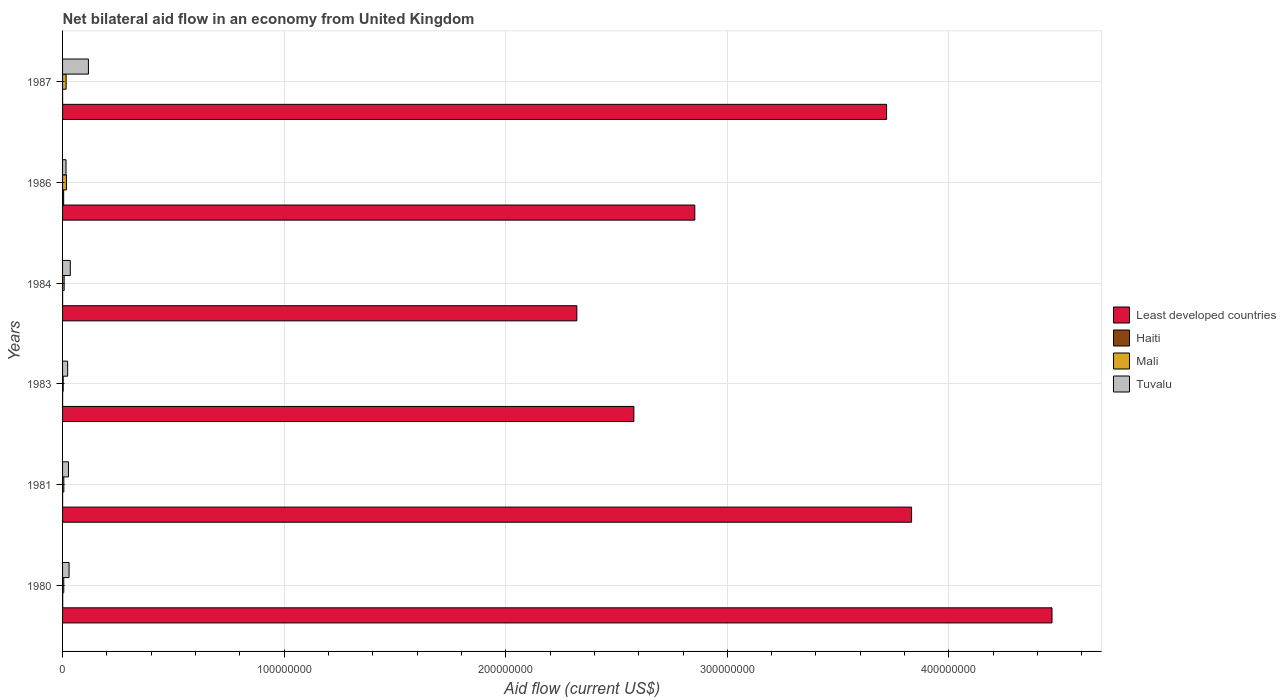How many different coloured bars are there?
Offer a terse response. 4. How many groups of bars are there?
Ensure brevity in your answer.  6. Are the number of bars per tick equal to the number of legend labels?
Offer a terse response. Yes. Are the number of bars on each tick of the Y-axis equal?
Your answer should be very brief. Yes. How many bars are there on the 1st tick from the top?
Make the answer very short. 4. How many bars are there on the 5th tick from the bottom?
Make the answer very short. 4. What is the label of the 4th group of bars from the top?
Your answer should be compact. 1983. What is the net bilateral aid flow in Least developed countries in 1986?
Your answer should be compact. 2.85e+08. Across all years, what is the maximum net bilateral aid flow in Haiti?
Keep it short and to the point. 4.90e+05. In which year was the net bilateral aid flow in Least developed countries maximum?
Give a very brief answer. 1980. What is the difference between the net bilateral aid flow in Least developed countries in 1980 and that in 1983?
Your response must be concise. 1.89e+08. What is the difference between the net bilateral aid flow in Haiti in 1981 and the net bilateral aid flow in Mali in 1986?
Ensure brevity in your answer.  -1.73e+06. What is the average net bilateral aid flow in Mali per year?
Provide a short and direct response. 9.10e+05. In the year 1981, what is the difference between the net bilateral aid flow in Tuvalu and net bilateral aid flow in Haiti?
Your answer should be very brief. 2.65e+06. In how many years, is the net bilateral aid flow in Haiti greater than 240000000 US$?
Give a very brief answer. 0. What is the ratio of the net bilateral aid flow in Least developed countries in 1981 to that in 1983?
Your response must be concise. 1.49. Is the net bilateral aid flow in Haiti in 1980 less than that in 1981?
Keep it short and to the point. No. Is the difference between the net bilateral aid flow in Tuvalu in 1980 and 1987 greater than the difference between the net bilateral aid flow in Haiti in 1980 and 1987?
Keep it short and to the point. No. What is the difference between the highest and the second highest net bilateral aid flow in Tuvalu?
Your answer should be compact. 8.18e+06. Is the sum of the net bilateral aid flow in Mali in 1984 and 1986 greater than the maximum net bilateral aid flow in Least developed countries across all years?
Give a very brief answer. No. What does the 2nd bar from the top in 1980 represents?
Keep it short and to the point. Mali. What does the 4th bar from the bottom in 1984 represents?
Provide a short and direct response. Tuvalu. Is it the case that in every year, the sum of the net bilateral aid flow in Mali and net bilateral aid flow in Least developed countries is greater than the net bilateral aid flow in Tuvalu?
Offer a terse response. Yes. How many bars are there?
Keep it short and to the point. 24. Are all the bars in the graph horizontal?
Give a very brief answer. Yes. How many years are there in the graph?
Offer a terse response. 6. What is the difference between two consecutive major ticks on the X-axis?
Make the answer very short. 1.00e+08. Are the values on the major ticks of X-axis written in scientific E-notation?
Keep it short and to the point. No. Does the graph contain any zero values?
Give a very brief answer. No. Does the graph contain grids?
Your answer should be compact. Yes. Where does the legend appear in the graph?
Provide a succinct answer. Center right. How many legend labels are there?
Your answer should be compact. 4. How are the legend labels stacked?
Provide a succinct answer. Vertical. What is the title of the graph?
Your answer should be compact. Net bilateral aid flow in an economy from United Kingdom. What is the label or title of the X-axis?
Your answer should be very brief. Aid flow (current US$). What is the label or title of the Y-axis?
Ensure brevity in your answer.  Years. What is the Aid flow (current US$) in Least developed countries in 1980?
Keep it short and to the point. 4.47e+08. What is the Aid flow (current US$) of Mali in 1980?
Ensure brevity in your answer.  5.40e+05. What is the Aid flow (current US$) of Tuvalu in 1980?
Offer a very short reply. 2.93e+06. What is the Aid flow (current US$) in Least developed countries in 1981?
Offer a very short reply. 3.83e+08. What is the Aid flow (current US$) in Haiti in 1981?
Make the answer very short. 10000. What is the Aid flow (current US$) in Mali in 1981?
Keep it short and to the point. 5.70e+05. What is the Aid flow (current US$) in Tuvalu in 1981?
Your response must be concise. 2.66e+06. What is the Aid flow (current US$) in Least developed countries in 1983?
Provide a succinct answer. 2.58e+08. What is the Aid flow (current US$) in Tuvalu in 1983?
Your answer should be very brief. 2.30e+06. What is the Aid flow (current US$) of Least developed countries in 1984?
Ensure brevity in your answer.  2.32e+08. What is the Aid flow (current US$) of Mali in 1984?
Keep it short and to the point. 7.10e+05. What is the Aid flow (current US$) in Tuvalu in 1984?
Provide a succinct answer. 3.49e+06. What is the Aid flow (current US$) of Least developed countries in 1986?
Provide a short and direct response. 2.85e+08. What is the Aid flow (current US$) in Mali in 1986?
Keep it short and to the point. 1.74e+06. What is the Aid flow (current US$) in Tuvalu in 1986?
Your response must be concise. 1.56e+06. What is the Aid flow (current US$) in Least developed countries in 1987?
Your response must be concise. 3.72e+08. What is the Aid flow (current US$) in Mali in 1987?
Keep it short and to the point. 1.61e+06. What is the Aid flow (current US$) of Tuvalu in 1987?
Make the answer very short. 1.17e+07. Across all years, what is the maximum Aid flow (current US$) of Least developed countries?
Your answer should be very brief. 4.47e+08. Across all years, what is the maximum Aid flow (current US$) in Mali?
Make the answer very short. 1.74e+06. Across all years, what is the maximum Aid flow (current US$) of Tuvalu?
Your answer should be compact. 1.17e+07. Across all years, what is the minimum Aid flow (current US$) in Least developed countries?
Provide a succinct answer. 2.32e+08. Across all years, what is the minimum Aid flow (current US$) in Haiti?
Ensure brevity in your answer.  10000. Across all years, what is the minimum Aid flow (current US$) in Mali?
Provide a short and direct response. 2.90e+05. Across all years, what is the minimum Aid flow (current US$) in Tuvalu?
Give a very brief answer. 1.56e+06. What is the total Aid flow (current US$) in Least developed countries in the graph?
Give a very brief answer. 1.98e+09. What is the total Aid flow (current US$) of Mali in the graph?
Your answer should be compact. 5.46e+06. What is the total Aid flow (current US$) in Tuvalu in the graph?
Your response must be concise. 2.46e+07. What is the difference between the Aid flow (current US$) in Least developed countries in 1980 and that in 1981?
Your response must be concise. 6.34e+07. What is the difference between the Aid flow (current US$) in Haiti in 1980 and that in 1981?
Give a very brief answer. 5.00e+04. What is the difference between the Aid flow (current US$) of Tuvalu in 1980 and that in 1981?
Make the answer very short. 2.70e+05. What is the difference between the Aid flow (current US$) in Least developed countries in 1980 and that in 1983?
Provide a short and direct response. 1.89e+08. What is the difference between the Aid flow (current US$) in Mali in 1980 and that in 1983?
Offer a terse response. 2.50e+05. What is the difference between the Aid flow (current US$) of Tuvalu in 1980 and that in 1983?
Ensure brevity in your answer.  6.30e+05. What is the difference between the Aid flow (current US$) in Least developed countries in 1980 and that in 1984?
Your answer should be compact. 2.14e+08. What is the difference between the Aid flow (current US$) in Haiti in 1980 and that in 1984?
Offer a terse response. 5.00e+04. What is the difference between the Aid flow (current US$) of Mali in 1980 and that in 1984?
Make the answer very short. -1.70e+05. What is the difference between the Aid flow (current US$) in Tuvalu in 1980 and that in 1984?
Your answer should be very brief. -5.60e+05. What is the difference between the Aid flow (current US$) in Least developed countries in 1980 and that in 1986?
Your response must be concise. 1.61e+08. What is the difference between the Aid flow (current US$) in Haiti in 1980 and that in 1986?
Offer a very short reply. -4.30e+05. What is the difference between the Aid flow (current US$) of Mali in 1980 and that in 1986?
Your response must be concise. -1.20e+06. What is the difference between the Aid flow (current US$) in Tuvalu in 1980 and that in 1986?
Give a very brief answer. 1.37e+06. What is the difference between the Aid flow (current US$) in Least developed countries in 1980 and that in 1987?
Give a very brief answer. 7.46e+07. What is the difference between the Aid flow (current US$) in Haiti in 1980 and that in 1987?
Ensure brevity in your answer.  5.00e+04. What is the difference between the Aid flow (current US$) of Mali in 1980 and that in 1987?
Your response must be concise. -1.07e+06. What is the difference between the Aid flow (current US$) of Tuvalu in 1980 and that in 1987?
Your answer should be very brief. -8.74e+06. What is the difference between the Aid flow (current US$) in Least developed countries in 1981 and that in 1983?
Provide a succinct answer. 1.25e+08. What is the difference between the Aid flow (current US$) of Least developed countries in 1981 and that in 1984?
Offer a terse response. 1.51e+08. What is the difference between the Aid flow (current US$) of Tuvalu in 1981 and that in 1984?
Make the answer very short. -8.30e+05. What is the difference between the Aid flow (current US$) of Least developed countries in 1981 and that in 1986?
Your answer should be very brief. 9.78e+07. What is the difference between the Aid flow (current US$) in Haiti in 1981 and that in 1986?
Your answer should be compact. -4.80e+05. What is the difference between the Aid flow (current US$) of Mali in 1981 and that in 1986?
Keep it short and to the point. -1.17e+06. What is the difference between the Aid flow (current US$) in Tuvalu in 1981 and that in 1986?
Your answer should be very brief. 1.10e+06. What is the difference between the Aid flow (current US$) of Least developed countries in 1981 and that in 1987?
Offer a terse response. 1.13e+07. What is the difference between the Aid flow (current US$) of Mali in 1981 and that in 1987?
Ensure brevity in your answer.  -1.04e+06. What is the difference between the Aid flow (current US$) of Tuvalu in 1981 and that in 1987?
Your response must be concise. -9.01e+06. What is the difference between the Aid flow (current US$) of Least developed countries in 1983 and that in 1984?
Offer a terse response. 2.57e+07. What is the difference between the Aid flow (current US$) in Haiti in 1983 and that in 1984?
Your answer should be very brief. 2.00e+04. What is the difference between the Aid flow (current US$) of Mali in 1983 and that in 1984?
Provide a succinct answer. -4.20e+05. What is the difference between the Aid flow (current US$) in Tuvalu in 1983 and that in 1984?
Offer a very short reply. -1.19e+06. What is the difference between the Aid flow (current US$) of Least developed countries in 1983 and that in 1986?
Ensure brevity in your answer.  -2.75e+07. What is the difference between the Aid flow (current US$) in Haiti in 1983 and that in 1986?
Your answer should be compact. -4.60e+05. What is the difference between the Aid flow (current US$) in Mali in 1983 and that in 1986?
Provide a short and direct response. -1.45e+06. What is the difference between the Aid flow (current US$) of Tuvalu in 1983 and that in 1986?
Ensure brevity in your answer.  7.40e+05. What is the difference between the Aid flow (current US$) of Least developed countries in 1983 and that in 1987?
Offer a terse response. -1.14e+08. What is the difference between the Aid flow (current US$) in Haiti in 1983 and that in 1987?
Offer a very short reply. 2.00e+04. What is the difference between the Aid flow (current US$) in Mali in 1983 and that in 1987?
Your answer should be compact. -1.32e+06. What is the difference between the Aid flow (current US$) in Tuvalu in 1983 and that in 1987?
Your response must be concise. -9.37e+06. What is the difference between the Aid flow (current US$) of Least developed countries in 1984 and that in 1986?
Give a very brief answer. -5.32e+07. What is the difference between the Aid flow (current US$) in Haiti in 1984 and that in 1986?
Your answer should be compact. -4.80e+05. What is the difference between the Aid flow (current US$) in Mali in 1984 and that in 1986?
Your response must be concise. -1.03e+06. What is the difference between the Aid flow (current US$) in Tuvalu in 1984 and that in 1986?
Your response must be concise. 1.93e+06. What is the difference between the Aid flow (current US$) in Least developed countries in 1984 and that in 1987?
Your answer should be compact. -1.40e+08. What is the difference between the Aid flow (current US$) of Haiti in 1984 and that in 1987?
Offer a terse response. 0. What is the difference between the Aid flow (current US$) in Mali in 1984 and that in 1987?
Provide a succinct answer. -9.00e+05. What is the difference between the Aid flow (current US$) in Tuvalu in 1984 and that in 1987?
Ensure brevity in your answer.  -8.18e+06. What is the difference between the Aid flow (current US$) in Least developed countries in 1986 and that in 1987?
Give a very brief answer. -8.66e+07. What is the difference between the Aid flow (current US$) of Haiti in 1986 and that in 1987?
Your response must be concise. 4.80e+05. What is the difference between the Aid flow (current US$) of Tuvalu in 1986 and that in 1987?
Offer a terse response. -1.01e+07. What is the difference between the Aid flow (current US$) of Least developed countries in 1980 and the Aid flow (current US$) of Haiti in 1981?
Ensure brevity in your answer.  4.46e+08. What is the difference between the Aid flow (current US$) in Least developed countries in 1980 and the Aid flow (current US$) in Mali in 1981?
Provide a succinct answer. 4.46e+08. What is the difference between the Aid flow (current US$) in Least developed countries in 1980 and the Aid flow (current US$) in Tuvalu in 1981?
Your answer should be very brief. 4.44e+08. What is the difference between the Aid flow (current US$) in Haiti in 1980 and the Aid flow (current US$) in Mali in 1981?
Provide a succinct answer. -5.10e+05. What is the difference between the Aid flow (current US$) of Haiti in 1980 and the Aid flow (current US$) of Tuvalu in 1981?
Offer a very short reply. -2.60e+06. What is the difference between the Aid flow (current US$) of Mali in 1980 and the Aid flow (current US$) of Tuvalu in 1981?
Your answer should be compact. -2.12e+06. What is the difference between the Aid flow (current US$) in Least developed countries in 1980 and the Aid flow (current US$) in Haiti in 1983?
Keep it short and to the point. 4.46e+08. What is the difference between the Aid flow (current US$) of Least developed countries in 1980 and the Aid flow (current US$) of Mali in 1983?
Your answer should be very brief. 4.46e+08. What is the difference between the Aid flow (current US$) in Least developed countries in 1980 and the Aid flow (current US$) in Tuvalu in 1983?
Provide a succinct answer. 4.44e+08. What is the difference between the Aid flow (current US$) of Haiti in 1980 and the Aid flow (current US$) of Mali in 1983?
Offer a terse response. -2.30e+05. What is the difference between the Aid flow (current US$) in Haiti in 1980 and the Aid flow (current US$) in Tuvalu in 1983?
Your response must be concise. -2.24e+06. What is the difference between the Aid flow (current US$) in Mali in 1980 and the Aid flow (current US$) in Tuvalu in 1983?
Keep it short and to the point. -1.76e+06. What is the difference between the Aid flow (current US$) in Least developed countries in 1980 and the Aid flow (current US$) in Haiti in 1984?
Your answer should be compact. 4.46e+08. What is the difference between the Aid flow (current US$) of Least developed countries in 1980 and the Aid flow (current US$) of Mali in 1984?
Make the answer very short. 4.46e+08. What is the difference between the Aid flow (current US$) in Least developed countries in 1980 and the Aid flow (current US$) in Tuvalu in 1984?
Your answer should be compact. 4.43e+08. What is the difference between the Aid flow (current US$) of Haiti in 1980 and the Aid flow (current US$) of Mali in 1984?
Keep it short and to the point. -6.50e+05. What is the difference between the Aid flow (current US$) in Haiti in 1980 and the Aid flow (current US$) in Tuvalu in 1984?
Provide a succinct answer. -3.43e+06. What is the difference between the Aid flow (current US$) of Mali in 1980 and the Aid flow (current US$) of Tuvalu in 1984?
Your answer should be very brief. -2.95e+06. What is the difference between the Aid flow (current US$) in Least developed countries in 1980 and the Aid flow (current US$) in Haiti in 1986?
Offer a very short reply. 4.46e+08. What is the difference between the Aid flow (current US$) of Least developed countries in 1980 and the Aid flow (current US$) of Mali in 1986?
Make the answer very short. 4.45e+08. What is the difference between the Aid flow (current US$) in Least developed countries in 1980 and the Aid flow (current US$) in Tuvalu in 1986?
Provide a succinct answer. 4.45e+08. What is the difference between the Aid flow (current US$) of Haiti in 1980 and the Aid flow (current US$) of Mali in 1986?
Make the answer very short. -1.68e+06. What is the difference between the Aid flow (current US$) of Haiti in 1980 and the Aid flow (current US$) of Tuvalu in 1986?
Offer a terse response. -1.50e+06. What is the difference between the Aid flow (current US$) in Mali in 1980 and the Aid flow (current US$) in Tuvalu in 1986?
Ensure brevity in your answer.  -1.02e+06. What is the difference between the Aid flow (current US$) of Least developed countries in 1980 and the Aid flow (current US$) of Haiti in 1987?
Give a very brief answer. 4.46e+08. What is the difference between the Aid flow (current US$) of Least developed countries in 1980 and the Aid flow (current US$) of Mali in 1987?
Provide a short and direct response. 4.45e+08. What is the difference between the Aid flow (current US$) of Least developed countries in 1980 and the Aid flow (current US$) of Tuvalu in 1987?
Provide a succinct answer. 4.35e+08. What is the difference between the Aid flow (current US$) of Haiti in 1980 and the Aid flow (current US$) of Mali in 1987?
Offer a very short reply. -1.55e+06. What is the difference between the Aid flow (current US$) of Haiti in 1980 and the Aid flow (current US$) of Tuvalu in 1987?
Keep it short and to the point. -1.16e+07. What is the difference between the Aid flow (current US$) of Mali in 1980 and the Aid flow (current US$) of Tuvalu in 1987?
Provide a short and direct response. -1.11e+07. What is the difference between the Aid flow (current US$) of Least developed countries in 1981 and the Aid flow (current US$) of Haiti in 1983?
Provide a succinct answer. 3.83e+08. What is the difference between the Aid flow (current US$) in Least developed countries in 1981 and the Aid flow (current US$) in Mali in 1983?
Offer a very short reply. 3.83e+08. What is the difference between the Aid flow (current US$) in Least developed countries in 1981 and the Aid flow (current US$) in Tuvalu in 1983?
Offer a very short reply. 3.81e+08. What is the difference between the Aid flow (current US$) in Haiti in 1981 and the Aid flow (current US$) in Mali in 1983?
Make the answer very short. -2.80e+05. What is the difference between the Aid flow (current US$) in Haiti in 1981 and the Aid flow (current US$) in Tuvalu in 1983?
Make the answer very short. -2.29e+06. What is the difference between the Aid flow (current US$) in Mali in 1981 and the Aid flow (current US$) in Tuvalu in 1983?
Offer a terse response. -1.73e+06. What is the difference between the Aid flow (current US$) in Least developed countries in 1981 and the Aid flow (current US$) in Haiti in 1984?
Ensure brevity in your answer.  3.83e+08. What is the difference between the Aid flow (current US$) of Least developed countries in 1981 and the Aid flow (current US$) of Mali in 1984?
Keep it short and to the point. 3.82e+08. What is the difference between the Aid flow (current US$) of Least developed countries in 1981 and the Aid flow (current US$) of Tuvalu in 1984?
Keep it short and to the point. 3.80e+08. What is the difference between the Aid flow (current US$) of Haiti in 1981 and the Aid flow (current US$) of Mali in 1984?
Offer a very short reply. -7.00e+05. What is the difference between the Aid flow (current US$) of Haiti in 1981 and the Aid flow (current US$) of Tuvalu in 1984?
Ensure brevity in your answer.  -3.48e+06. What is the difference between the Aid flow (current US$) in Mali in 1981 and the Aid flow (current US$) in Tuvalu in 1984?
Your answer should be very brief. -2.92e+06. What is the difference between the Aid flow (current US$) in Least developed countries in 1981 and the Aid flow (current US$) in Haiti in 1986?
Provide a short and direct response. 3.83e+08. What is the difference between the Aid flow (current US$) in Least developed countries in 1981 and the Aid flow (current US$) in Mali in 1986?
Your response must be concise. 3.81e+08. What is the difference between the Aid flow (current US$) of Least developed countries in 1981 and the Aid flow (current US$) of Tuvalu in 1986?
Ensure brevity in your answer.  3.82e+08. What is the difference between the Aid flow (current US$) in Haiti in 1981 and the Aid flow (current US$) in Mali in 1986?
Make the answer very short. -1.73e+06. What is the difference between the Aid flow (current US$) in Haiti in 1981 and the Aid flow (current US$) in Tuvalu in 1986?
Make the answer very short. -1.55e+06. What is the difference between the Aid flow (current US$) in Mali in 1981 and the Aid flow (current US$) in Tuvalu in 1986?
Keep it short and to the point. -9.90e+05. What is the difference between the Aid flow (current US$) in Least developed countries in 1981 and the Aid flow (current US$) in Haiti in 1987?
Your answer should be very brief. 3.83e+08. What is the difference between the Aid flow (current US$) in Least developed countries in 1981 and the Aid flow (current US$) in Mali in 1987?
Keep it short and to the point. 3.82e+08. What is the difference between the Aid flow (current US$) of Least developed countries in 1981 and the Aid flow (current US$) of Tuvalu in 1987?
Offer a very short reply. 3.71e+08. What is the difference between the Aid flow (current US$) of Haiti in 1981 and the Aid flow (current US$) of Mali in 1987?
Provide a short and direct response. -1.60e+06. What is the difference between the Aid flow (current US$) of Haiti in 1981 and the Aid flow (current US$) of Tuvalu in 1987?
Your response must be concise. -1.17e+07. What is the difference between the Aid flow (current US$) of Mali in 1981 and the Aid flow (current US$) of Tuvalu in 1987?
Keep it short and to the point. -1.11e+07. What is the difference between the Aid flow (current US$) in Least developed countries in 1983 and the Aid flow (current US$) in Haiti in 1984?
Give a very brief answer. 2.58e+08. What is the difference between the Aid flow (current US$) of Least developed countries in 1983 and the Aid flow (current US$) of Mali in 1984?
Your response must be concise. 2.57e+08. What is the difference between the Aid flow (current US$) of Least developed countries in 1983 and the Aid flow (current US$) of Tuvalu in 1984?
Your answer should be compact. 2.54e+08. What is the difference between the Aid flow (current US$) of Haiti in 1983 and the Aid flow (current US$) of Mali in 1984?
Your answer should be very brief. -6.80e+05. What is the difference between the Aid flow (current US$) in Haiti in 1983 and the Aid flow (current US$) in Tuvalu in 1984?
Your answer should be compact. -3.46e+06. What is the difference between the Aid flow (current US$) of Mali in 1983 and the Aid flow (current US$) of Tuvalu in 1984?
Provide a short and direct response. -3.20e+06. What is the difference between the Aid flow (current US$) of Least developed countries in 1983 and the Aid flow (current US$) of Haiti in 1986?
Provide a short and direct response. 2.57e+08. What is the difference between the Aid flow (current US$) of Least developed countries in 1983 and the Aid flow (current US$) of Mali in 1986?
Your answer should be compact. 2.56e+08. What is the difference between the Aid flow (current US$) in Least developed countries in 1983 and the Aid flow (current US$) in Tuvalu in 1986?
Your answer should be very brief. 2.56e+08. What is the difference between the Aid flow (current US$) in Haiti in 1983 and the Aid flow (current US$) in Mali in 1986?
Provide a short and direct response. -1.71e+06. What is the difference between the Aid flow (current US$) in Haiti in 1983 and the Aid flow (current US$) in Tuvalu in 1986?
Provide a succinct answer. -1.53e+06. What is the difference between the Aid flow (current US$) in Mali in 1983 and the Aid flow (current US$) in Tuvalu in 1986?
Give a very brief answer. -1.27e+06. What is the difference between the Aid flow (current US$) of Least developed countries in 1983 and the Aid flow (current US$) of Haiti in 1987?
Make the answer very short. 2.58e+08. What is the difference between the Aid flow (current US$) of Least developed countries in 1983 and the Aid flow (current US$) of Mali in 1987?
Give a very brief answer. 2.56e+08. What is the difference between the Aid flow (current US$) in Least developed countries in 1983 and the Aid flow (current US$) in Tuvalu in 1987?
Your answer should be compact. 2.46e+08. What is the difference between the Aid flow (current US$) of Haiti in 1983 and the Aid flow (current US$) of Mali in 1987?
Make the answer very short. -1.58e+06. What is the difference between the Aid flow (current US$) in Haiti in 1983 and the Aid flow (current US$) in Tuvalu in 1987?
Give a very brief answer. -1.16e+07. What is the difference between the Aid flow (current US$) in Mali in 1983 and the Aid flow (current US$) in Tuvalu in 1987?
Provide a succinct answer. -1.14e+07. What is the difference between the Aid flow (current US$) in Least developed countries in 1984 and the Aid flow (current US$) in Haiti in 1986?
Ensure brevity in your answer.  2.32e+08. What is the difference between the Aid flow (current US$) in Least developed countries in 1984 and the Aid flow (current US$) in Mali in 1986?
Offer a very short reply. 2.30e+08. What is the difference between the Aid flow (current US$) in Least developed countries in 1984 and the Aid flow (current US$) in Tuvalu in 1986?
Offer a terse response. 2.31e+08. What is the difference between the Aid flow (current US$) in Haiti in 1984 and the Aid flow (current US$) in Mali in 1986?
Offer a very short reply. -1.73e+06. What is the difference between the Aid flow (current US$) in Haiti in 1984 and the Aid flow (current US$) in Tuvalu in 1986?
Ensure brevity in your answer.  -1.55e+06. What is the difference between the Aid flow (current US$) of Mali in 1984 and the Aid flow (current US$) of Tuvalu in 1986?
Provide a succinct answer. -8.50e+05. What is the difference between the Aid flow (current US$) of Least developed countries in 1984 and the Aid flow (current US$) of Haiti in 1987?
Offer a very short reply. 2.32e+08. What is the difference between the Aid flow (current US$) of Least developed countries in 1984 and the Aid flow (current US$) of Mali in 1987?
Ensure brevity in your answer.  2.30e+08. What is the difference between the Aid flow (current US$) of Least developed countries in 1984 and the Aid flow (current US$) of Tuvalu in 1987?
Give a very brief answer. 2.20e+08. What is the difference between the Aid flow (current US$) in Haiti in 1984 and the Aid flow (current US$) in Mali in 1987?
Your answer should be compact. -1.60e+06. What is the difference between the Aid flow (current US$) in Haiti in 1984 and the Aid flow (current US$) in Tuvalu in 1987?
Provide a short and direct response. -1.17e+07. What is the difference between the Aid flow (current US$) in Mali in 1984 and the Aid flow (current US$) in Tuvalu in 1987?
Ensure brevity in your answer.  -1.10e+07. What is the difference between the Aid flow (current US$) in Least developed countries in 1986 and the Aid flow (current US$) in Haiti in 1987?
Offer a very short reply. 2.85e+08. What is the difference between the Aid flow (current US$) of Least developed countries in 1986 and the Aid flow (current US$) of Mali in 1987?
Give a very brief answer. 2.84e+08. What is the difference between the Aid flow (current US$) in Least developed countries in 1986 and the Aid flow (current US$) in Tuvalu in 1987?
Your answer should be compact. 2.74e+08. What is the difference between the Aid flow (current US$) in Haiti in 1986 and the Aid flow (current US$) in Mali in 1987?
Give a very brief answer. -1.12e+06. What is the difference between the Aid flow (current US$) of Haiti in 1986 and the Aid flow (current US$) of Tuvalu in 1987?
Provide a succinct answer. -1.12e+07. What is the difference between the Aid flow (current US$) in Mali in 1986 and the Aid flow (current US$) in Tuvalu in 1987?
Your response must be concise. -9.93e+06. What is the average Aid flow (current US$) in Least developed countries per year?
Your answer should be very brief. 3.29e+08. What is the average Aid flow (current US$) in Haiti per year?
Offer a terse response. 1.02e+05. What is the average Aid flow (current US$) in Mali per year?
Provide a succinct answer. 9.10e+05. What is the average Aid flow (current US$) of Tuvalu per year?
Keep it short and to the point. 4.10e+06. In the year 1980, what is the difference between the Aid flow (current US$) in Least developed countries and Aid flow (current US$) in Haiti?
Your answer should be very brief. 4.46e+08. In the year 1980, what is the difference between the Aid flow (current US$) of Least developed countries and Aid flow (current US$) of Mali?
Offer a terse response. 4.46e+08. In the year 1980, what is the difference between the Aid flow (current US$) in Least developed countries and Aid flow (current US$) in Tuvalu?
Make the answer very short. 4.44e+08. In the year 1980, what is the difference between the Aid flow (current US$) of Haiti and Aid flow (current US$) of Mali?
Offer a very short reply. -4.80e+05. In the year 1980, what is the difference between the Aid flow (current US$) in Haiti and Aid flow (current US$) in Tuvalu?
Give a very brief answer. -2.87e+06. In the year 1980, what is the difference between the Aid flow (current US$) of Mali and Aid flow (current US$) of Tuvalu?
Offer a very short reply. -2.39e+06. In the year 1981, what is the difference between the Aid flow (current US$) in Least developed countries and Aid flow (current US$) in Haiti?
Your response must be concise. 3.83e+08. In the year 1981, what is the difference between the Aid flow (current US$) in Least developed countries and Aid flow (current US$) in Mali?
Your answer should be very brief. 3.83e+08. In the year 1981, what is the difference between the Aid flow (current US$) in Least developed countries and Aid flow (current US$) in Tuvalu?
Provide a succinct answer. 3.80e+08. In the year 1981, what is the difference between the Aid flow (current US$) of Haiti and Aid flow (current US$) of Mali?
Provide a succinct answer. -5.60e+05. In the year 1981, what is the difference between the Aid flow (current US$) in Haiti and Aid flow (current US$) in Tuvalu?
Ensure brevity in your answer.  -2.65e+06. In the year 1981, what is the difference between the Aid flow (current US$) in Mali and Aid flow (current US$) in Tuvalu?
Your response must be concise. -2.09e+06. In the year 1983, what is the difference between the Aid flow (current US$) of Least developed countries and Aid flow (current US$) of Haiti?
Offer a very short reply. 2.58e+08. In the year 1983, what is the difference between the Aid flow (current US$) in Least developed countries and Aid flow (current US$) in Mali?
Ensure brevity in your answer.  2.58e+08. In the year 1983, what is the difference between the Aid flow (current US$) of Least developed countries and Aid flow (current US$) of Tuvalu?
Provide a succinct answer. 2.56e+08. In the year 1983, what is the difference between the Aid flow (current US$) of Haiti and Aid flow (current US$) of Tuvalu?
Provide a succinct answer. -2.27e+06. In the year 1983, what is the difference between the Aid flow (current US$) of Mali and Aid flow (current US$) of Tuvalu?
Offer a terse response. -2.01e+06. In the year 1984, what is the difference between the Aid flow (current US$) of Least developed countries and Aid flow (current US$) of Haiti?
Ensure brevity in your answer.  2.32e+08. In the year 1984, what is the difference between the Aid flow (current US$) in Least developed countries and Aid flow (current US$) in Mali?
Offer a very short reply. 2.31e+08. In the year 1984, what is the difference between the Aid flow (current US$) in Least developed countries and Aid flow (current US$) in Tuvalu?
Make the answer very short. 2.29e+08. In the year 1984, what is the difference between the Aid flow (current US$) of Haiti and Aid flow (current US$) of Mali?
Make the answer very short. -7.00e+05. In the year 1984, what is the difference between the Aid flow (current US$) in Haiti and Aid flow (current US$) in Tuvalu?
Provide a short and direct response. -3.48e+06. In the year 1984, what is the difference between the Aid flow (current US$) of Mali and Aid flow (current US$) of Tuvalu?
Give a very brief answer. -2.78e+06. In the year 1986, what is the difference between the Aid flow (current US$) of Least developed countries and Aid flow (current US$) of Haiti?
Your answer should be compact. 2.85e+08. In the year 1986, what is the difference between the Aid flow (current US$) of Least developed countries and Aid flow (current US$) of Mali?
Ensure brevity in your answer.  2.84e+08. In the year 1986, what is the difference between the Aid flow (current US$) in Least developed countries and Aid flow (current US$) in Tuvalu?
Offer a very short reply. 2.84e+08. In the year 1986, what is the difference between the Aid flow (current US$) in Haiti and Aid flow (current US$) in Mali?
Provide a succinct answer. -1.25e+06. In the year 1986, what is the difference between the Aid flow (current US$) in Haiti and Aid flow (current US$) in Tuvalu?
Ensure brevity in your answer.  -1.07e+06. In the year 1986, what is the difference between the Aid flow (current US$) in Mali and Aid flow (current US$) in Tuvalu?
Your answer should be very brief. 1.80e+05. In the year 1987, what is the difference between the Aid flow (current US$) in Least developed countries and Aid flow (current US$) in Haiti?
Your answer should be compact. 3.72e+08. In the year 1987, what is the difference between the Aid flow (current US$) in Least developed countries and Aid flow (current US$) in Mali?
Ensure brevity in your answer.  3.70e+08. In the year 1987, what is the difference between the Aid flow (current US$) of Least developed countries and Aid flow (current US$) of Tuvalu?
Your answer should be compact. 3.60e+08. In the year 1987, what is the difference between the Aid flow (current US$) of Haiti and Aid flow (current US$) of Mali?
Offer a terse response. -1.60e+06. In the year 1987, what is the difference between the Aid flow (current US$) of Haiti and Aid flow (current US$) of Tuvalu?
Your answer should be compact. -1.17e+07. In the year 1987, what is the difference between the Aid flow (current US$) of Mali and Aid flow (current US$) of Tuvalu?
Offer a terse response. -1.01e+07. What is the ratio of the Aid flow (current US$) of Least developed countries in 1980 to that in 1981?
Your response must be concise. 1.17. What is the ratio of the Aid flow (current US$) in Haiti in 1980 to that in 1981?
Give a very brief answer. 6. What is the ratio of the Aid flow (current US$) in Tuvalu in 1980 to that in 1981?
Provide a succinct answer. 1.1. What is the ratio of the Aid flow (current US$) of Least developed countries in 1980 to that in 1983?
Your response must be concise. 1.73. What is the ratio of the Aid flow (current US$) in Mali in 1980 to that in 1983?
Provide a succinct answer. 1.86. What is the ratio of the Aid flow (current US$) in Tuvalu in 1980 to that in 1983?
Offer a very short reply. 1.27. What is the ratio of the Aid flow (current US$) in Least developed countries in 1980 to that in 1984?
Your answer should be very brief. 1.92. What is the ratio of the Aid flow (current US$) of Mali in 1980 to that in 1984?
Offer a terse response. 0.76. What is the ratio of the Aid flow (current US$) of Tuvalu in 1980 to that in 1984?
Provide a succinct answer. 0.84. What is the ratio of the Aid flow (current US$) in Least developed countries in 1980 to that in 1986?
Keep it short and to the point. 1.56. What is the ratio of the Aid flow (current US$) in Haiti in 1980 to that in 1986?
Provide a short and direct response. 0.12. What is the ratio of the Aid flow (current US$) in Mali in 1980 to that in 1986?
Make the answer very short. 0.31. What is the ratio of the Aid flow (current US$) in Tuvalu in 1980 to that in 1986?
Provide a short and direct response. 1.88. What is the ratio of the Aid flow (current US$) in Least developed countries in 1980 to that in 1987?
Give a very brief answer. 1.2. What is the ratio of the Aid flow (current US$) in Haiti in 1980 to that in 1987?
Keep it short and to the point. 6. What is the ratio of the Aid flow (current US$) of Mali in 1980 to that in 1987?
Provide a succinct answer. 0.34. What is the ratio of the Aid flow (current US$) of Tuvalu in 1980 to that in 1987?
Offer a very short reply. 0.25. What is the ratio of the Aid flow (current US$) in Least developed countries in 1981 to that in 1983?
Provide a succinct answer. 1.49. What is the ratio of the Aid flow (current US$) in Haiti in 1981 to that in 1983?
Your answer should be very brief. 0.33. What is the ratio of the Aid flow (current US$) of Mali in 1981 to that in 1983?
Provide a short and direct response. 1.97. What is the ratio of the Aid flow (current US$) of Tuvalu in 1981 to that in 1983?
Provide a short and direct response. 1.16. What is the ratio of the Aid flow (current US$) of Least developed countries in 1981 to that in 1984?
Provide a short and direct response. 1.65. What is the ratio of the Aid flow (current US$) of Mali in 1981 to that in 1984?
Your response must be concise. 0.8. What is the ratio of the Aid flow (current US$) in Tuvalu in 1981 to that in 1984?
Your answer should be compact. 0.76. What is the ratio of the Aid flow (current US$) in Least developed countries in 1981 to that in 1986?
Provide a short and direct response. 1.34. What is the ratio of the Aid flow (current US$) in Haiti in 1981 to that in 1986?
Give a very brief answer. 0.02. What is the ratio of the Aid flow (current US$) of Mali in 1981 to that in 1986?
Your answer should be very brief. 0.33. What is the ratio of the Aid flow (current US$) of Tuvalu in 1981 to that in 1986?
Offer a terse response. 1.71. What is the ratio of the Aid flow (current US$) of Least developed countries in 1981 to that in 1987?
Ensure brevity in your answer.  1.03. What is the ratio of the Aid flow (current US$) in Haiti in 1981 to that in 1987?
Provide a short and direct response. 1. What is the ratio of the Aid flow (current US$) of Mali in 1981 to that in 1987?
Keep it short and to the point. 0.35. What is the ratio of the Aid flow (current US$) of Tuvalu in 1981 to that in 1987?
Your answer should be very brief. 0.23. What is the ratio of the Aid flow (current US$) in Least developed countries in 1983 to that in 1984?
Your answer should be very brief. 1.11. What is the ratio of the Aid flow (current US$) in Haiti in 1983 to that in 1984?
Provide a succinct answer. 3. What is the ratio of the Aid flow (current US$) in Mali in 1983 to that in 1984?
Provide a succinct answer. 0.41. What is the ratio of the Aid flow (current US$) in Tuvalu in 1983 to that in 1984?
Provide a succinct answer. 0.66. What is the ratio of the Aid flow (current US$) of Least developed countries in 1983 to that in 1986?
Offer a very short reply. 0.9. What is the ratio of the Aid flow (current US$) of Haiti in 1983 to that in 1986?
Offer a terse response. 0.06. What is the ratio of the Aid flow (current US$) of Tuvalu in 1983 to that in 1986?
Ensure brevity in your answer.  1.47. What is the ratio of the Aid flow (current US$) of Least developed countries in 1983 to that in 1987?
Provide a short and direct response. 0.69. What is the ratio of the Aid flow (current US$) in Mali in 1983 to that in 1987?
Offer a terse response. 0.18. What is the ratio of the Aid flow (current US$) of Tuvalu in 1983 to that in 1987?
Give a very brief answer. 0.2. What is the ratio of the Aid flow (current US$) of Least developed countries in 1984 to that in 1986?
Give a very brief answer. 0.81. What is the ratio of the Aid flow (current US$) of Haiti in 1984 to that in 1986?
Provide a short and direct response. 0.02. What is the ratio of the Aid flow (current US$) in Mali in 1984 to that in 1986?
Offer a very short reply. 0.41. What is the ratio of the Aid flow (current US$) in Tuvalu in 1984 to that in 1986?
Make the answer very short. 2.24. What is the ratio of the Aid flow (current US$) in Least developed countries in 1984 to that in 1987?
Keep it short and to the point. 0.62. What is the ratio of the Aid flow (current US$) of Mali in 1984 to that in 1987?
Offer a terse response. 0.44. What is the ratio of the Aid flow (current US$) of Tuvalu in 1984 to that in 1987?
Your answer should be very brief. 0.3. What is the ratio of the Aid flow (current US$) in Least developed countries in 1986 to that in 1987?
Provide a succinct answer. 0.77. What is the ratio of the Aid flow (current US$) in Haiti in 1986 to that in 1987?
Your answer should be very brief. 49. What is the ratio of the Aid flow (current US$) of Mali in 1986 to that in 1987?
Make the answer very short. 1.08. What is the ratio of the Aid flow (current US$) in Tuvalu in 1986 to that in 1987?
Make the answer very short. 0.13. What is the difference between the highest and the second highest Aid flow (current US$) in Least developed countries?
Provide a short and direct response. 6.34e+07. What is the difference between the highest and the second highest Aid flow (current US$) in Mali?
Make the answer very short. 1.30e+05. What is the difference between the highest and the second highest Aid flow (current US$) of Tuvalu?
Make the answer very short. 8.18e+06. What is the difference between the highest and the lowest Aid flow (current US$) of Least developed countries?
Provide a short and direct response. 2.14e+08. What is the difference between the highest and the lowest Aid flow (current US$) of Haiti?
Ensure brevity in your answer.  4.80e+05. What is the difference between the highest and the lowest Aid flow (current US$) of Mali?
Ensure brevity in your answer.  1.45e+06. What is the difference between the highest and the lowest Aid flow (current US$) in Tuvalu?
Provide a short and direct response. 1.01e+07. 